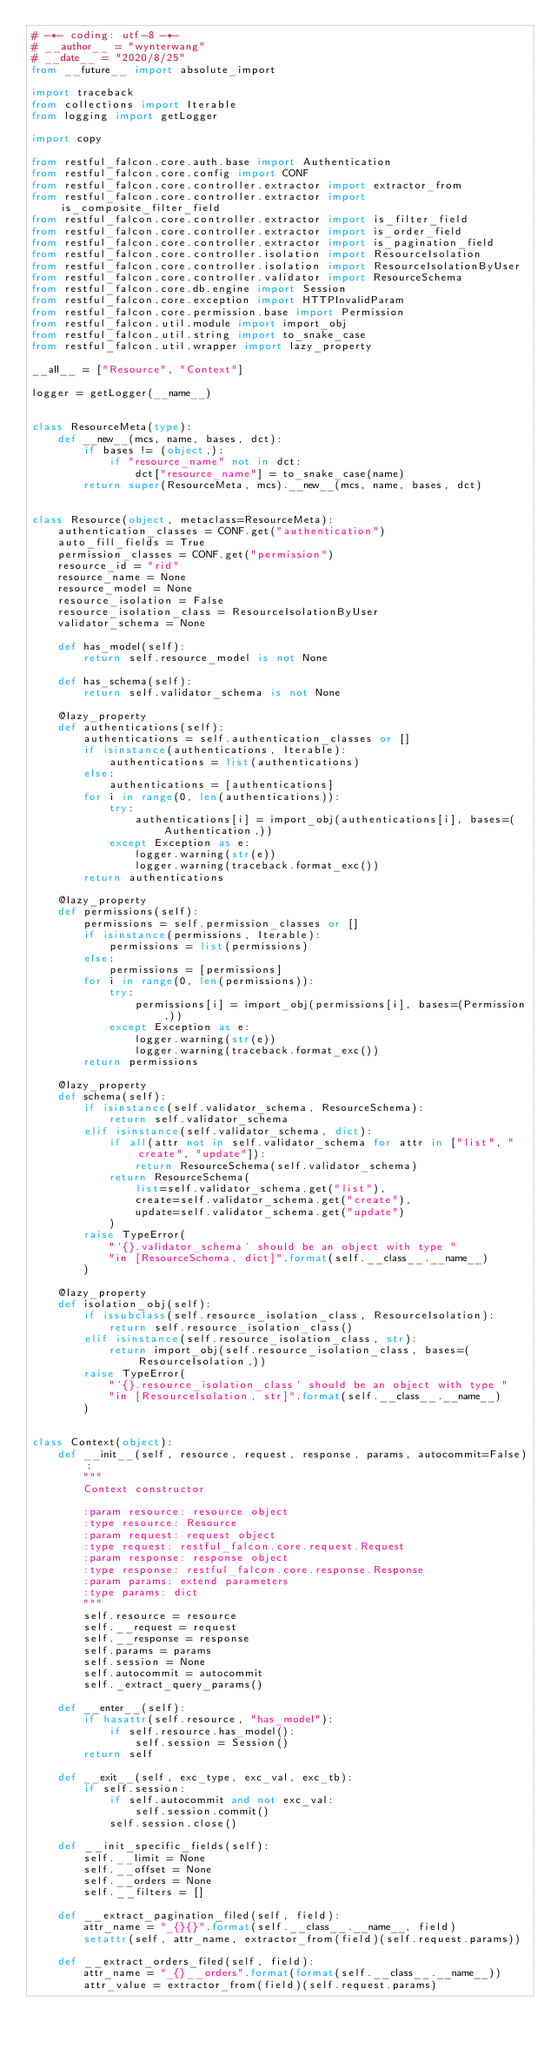Convert code to text. <code><loc_0><loc_0><loc_500><loc_500><_Python_># -*- coding: utf-8 -*-
# __author__ = "wynterwang"
# __date__ = "2020/8/25"
from __future__ import absolute_import

import traceback
from collections import Iterable
from logging import getLogger

import copy

from restful_falcon.core.auth.base import Authentication
from restful_falcon.core.config import CONF
from restful_falcon.core.controller.extractor import extractor_from
from restful_falcon.core.controller.extractor import is_composite_filter_field
from restful_falcon.core.controller.extractor import is_filter_field
from restful_falcon.core.controller.extractor import is_order_field
from restful_falcon.core.controller.extractor import is_pagination_field
from restful_falcon.core.controller.isolation import ResourceIsolation
from restful_falcon.core.controller.isolation import ResourceIsolationByUser
from restful_falcon.core.controller.validator import ResourceSchema
from restful_falcon.core.db.engine import Session
from restful_falcon.core.exception import HTTPInvalidParam
from restful_falcon.core.permission.base import Permission
from restful_falcon.util.module import import_obj
from restful_falcon.util.string import to_snake_case
from restful_falcon.util.wrapper import lazy_property

__all__ = ["Resource", "Context"]

logger = getLogger(__name__)


class ResourceMeta(type):
    def __new__(mcs, name, bases, dct):
        if bases != (object,):
            if "resource_name" not in dct:
                dct["resource_name"] = to_snake_case(name)
        return super(ResourceMeta, mcs).__new__(mcs, name, bases, dct)


class Resource(object, metaclass=ResourceMeta):
    authentication_classes = CONF.get("authentication")
    auto_fill_fields = True
    permission_classes = CONF.get("permission")
    resource_id = "rid"
    resource_name = None
    resource_model = None
    resource_isolation = False
    resource_isolation_class = ResourceIsolationByUser
    validator_schema = None

    def has_model(self):
        return self.resource_model is not None

    def has_schema(self):
        return self.validator_schema is not None

    @lazy_property
    def authentications(self):
        authentications = self.authentication_classes or []
        if isinstance(authentications, Iterable):
            authentications = list(authentications)
        else:
            authentications = [authentications]
        for i in range(0, len(authentications)):
            try:
                authentications[i] = import_obj(authentications[i], bases=(Authentication,))
            except Exception as e:
                logger.warning(str(e))
                logger.warning(traceback.format_exc())
        return authentications

    @lazy_property
    def permissions(self):
        permissions = self.permission_classes or []
        if isinstance(permissions, Iterable):
            permissions = list(permissions)
        else:
            permissions = [permissions]
        for i in range(0, len(permissions)):
            try:
                permissions[i] = import_obj(permissions[i], bases=(Permission,))
            except Exception as e:
                logger.warning(str(e))
                logger.warning(traceback.format_exc())
        return permissions

    @lazy_property
    def schema(self):
        if isinstance(self.validator_schema, ResourceSchema):
            return self.validator_schema
        elif isinstance(self.validator_schema, dict):
            if all(attr not in self.validator_schema for attr in ["list", "create", "update"]):
                return ResourceSchema(self.validator_schema)
            return ResourceSchema(
                list=self.validator_schema.get("list"),
                create=self.validator_schema.get("create"),
                update=self.validator_schema.get("update")
            )
        raise TypeError(
            "`{}.validator_schema` should be an object with type "
            "in [ResourceSchema, dict]".format(self.__class__.__name__)
        )

    @lazy_property
    def isolation_obj(self):
        if issubclass(self.resource_isolation_class, ResourceIsolation):
            return self.resource_isolation_class()
        elif isinstance(self.resource_isolation_class, str):
            return import_obj(self.resource_isolation_class, bases=(ResourceIsolation,))
        raise TypeError(
            "`{}.resource_isolation_class` should be an object with type "
            "in [ResourceIsolation, str]".format(self.__class__.__name__)
        )


class Context(object):
    def __init__(self, resource, request, response, params, autocommit=False):
        """
        Context constructor

        :param resource: resource object
        :type resource: Resource
        :param request: request object
        :type request: restful_falcon.core.request.Request
        :param response: response object
        :type response: restful_falcon.core.response.Response
        :param params: extend parameters
        :type params: dict
        """
        self.resource = resource
        self.__request = request
        self.__response = response
        self.params = params
        self.session = None
        self.autocommit = autocommit
        self._extract_query_params()

    def __enter__(self):
        if hasattr(self.resource, "has_model"):
            if self.resource.has_model():
                self.session = Session()
        return self

    def __exit__(self, exc_type, exc_val, exc_tb):
        if self.session:
            if self.autocommit and not exc_val:
                self.session.commit()
            self.session.close()

    def __init_specific_fields(self):
        self.__limit = None
        self.__offset = None
        self.__orders = None
        self.__filters = []

    def __extract_pagination_filed(self, field):
        attr_name = "_{}{}".format(self.__class__.__name__, field)
        setattr(self, attr_name, extractor_from(field)(self.request.params))

    def __extract_orders_filed(self, field):
        attr_name = "_{}__orders".format(format(self.__class__.__name__))
        attr_value = extractor_from(field)(self.request.params)</code> 